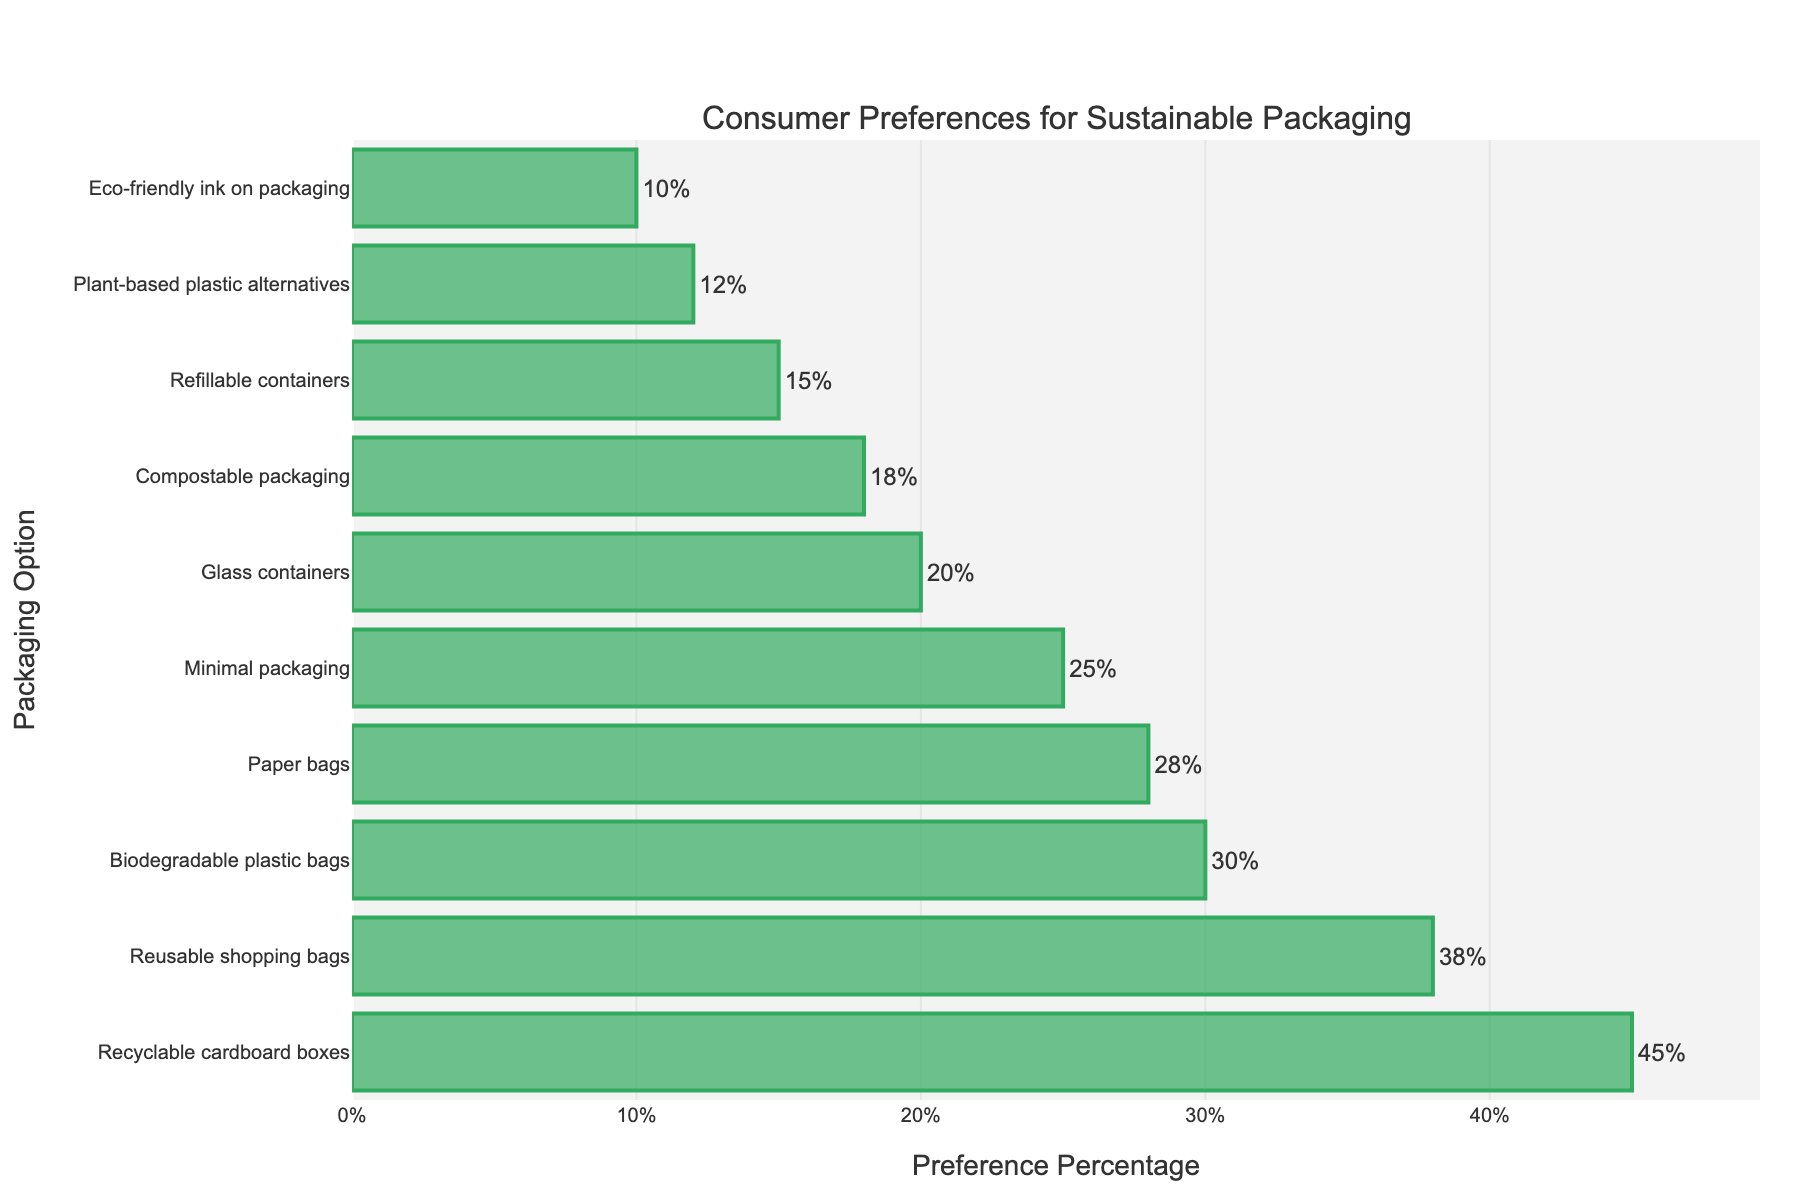What is the most preferred sustainable packaging option according to the consumers? The bar chart shows consumer preferences for various sustainable packaging options with preference percentages. The longest bar corresponds to the highest preference percentage, which is for "Recyclable cardboard boxes" at 45%.
Answer: Recyclable cardboard boxes Which packaging option has a preference percentage closest to 20%? To find this, we look at the bar corresponding to a preference percentage around 20%. "Glass containers" have a preference percentage of 20%, matching exactly.
Answer: Glass containers How much more preferred are Recyclable cardboard boxes compared to Plant-based plastic alternatives? The preference percentage for "Recyclable cardboard boxes" is 45% and for "Plant-based plastic alternatives" is 12%. The difference is 45% - 12% = 33%.
Answer: 33% Which packaging option ranks third in terms of consumer preference? To determine this, we need to identify the third longest bar from the top. The third longest bar in descending order is for "Biodegradable plastic bags" with 30% preference.
Answer: Biodegradable plastic bags What is the combined preference percentage of the top three most preferred options? The top three options are "Recyclable cardboard boxes" (45%), "Reusable shopping bags" (38%), and "Biodegradable plastic bags" (30%). Adding these gives 45% + 38% + 30% = 113%.
Answer: 113% How does the preference for Minimal packaging compare to Compostable packaging? "Minimal packaging" has a preference percentage of 25%, while "Compostable packaging" has 18%. Comparing these, Minimal packaging has a higher preference by 25% - 18% = 7%.
Answer: 7% What is the total preference percentage for all listed sustainable packaging options? Summing up the preference percentages of all listed options: 45% + 38% + 30% + 28% + 25% + 20% + 18% + 15% + 12% + 10% = 241%.
Answer: 241% Which packaging options have a preference percentage below 20%? To identify these, we look at bars with preference percentages below 20%. These options are "Compostable packaging" (18%), "Refillable containers" (15%), "Plant-based plastic alternatives" (12%), and "Eco-friendly ink on packaging" (10%).
Answer: Compostable packaging, Refillable containers, Plant-based plastic alternatives, Eco-friendly ink on packaging What is the difference in preference percentage between the least and the most preferred packaging options? The most preferred option is "Recyclable cardboard boxes" with 45%, and the least preferred is "Eco-friendly ink on packaging" with 10%. The difference is 45% - 10% = 35%.
Answer: 35% 